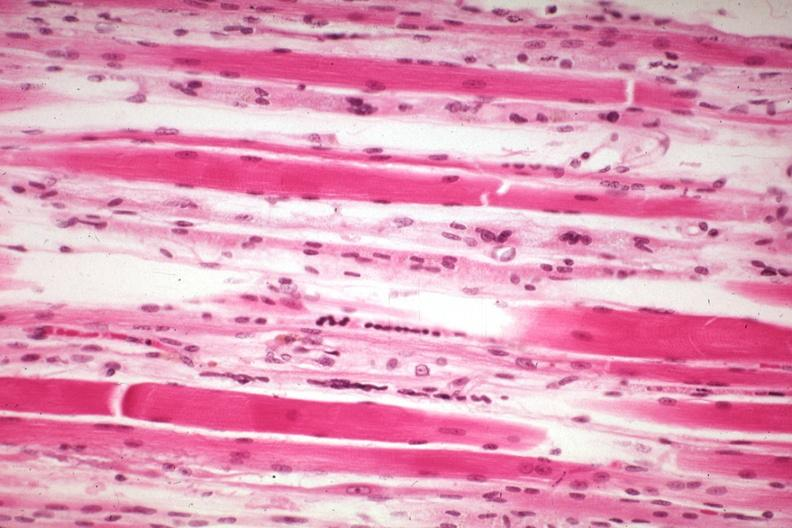what is present?
Answer the question using a single word or phrase. Soft tissue 